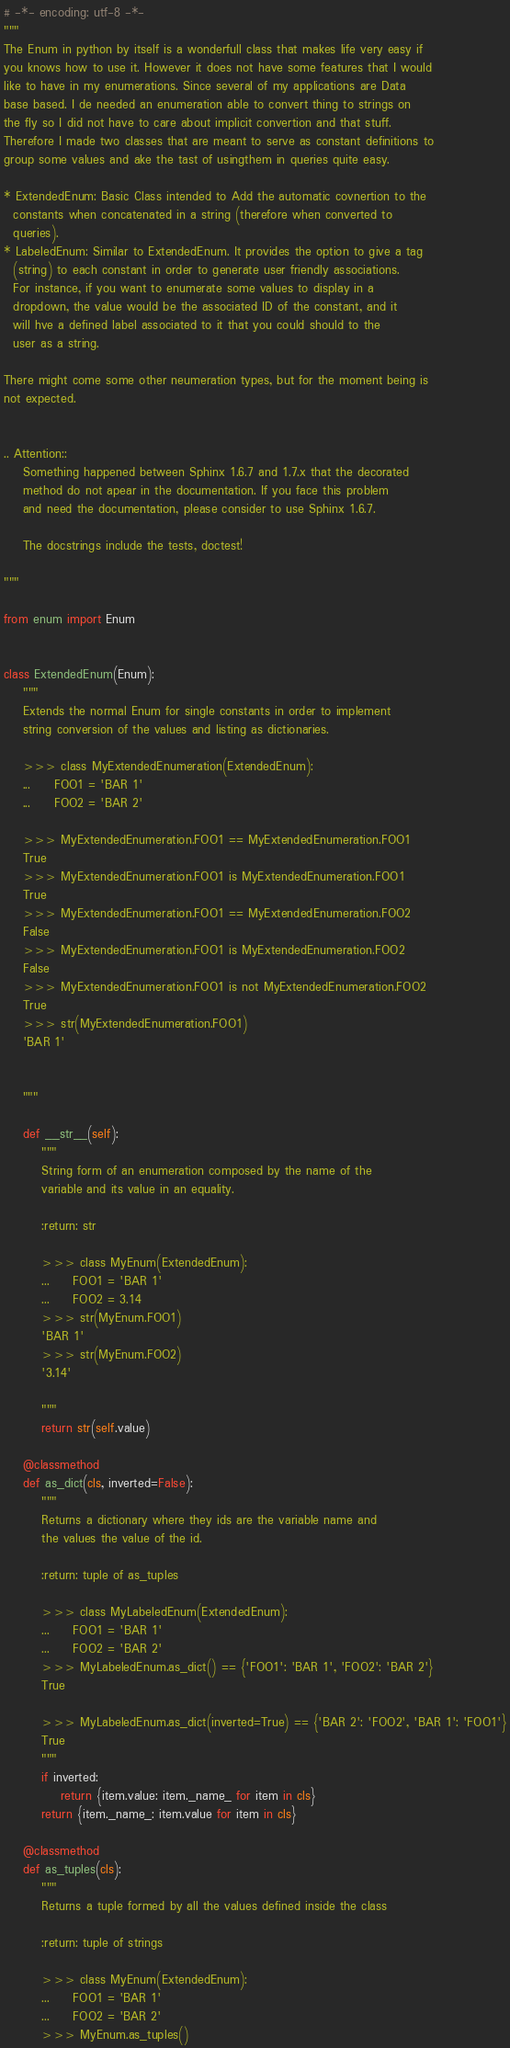<code> <loc_0><loc_0><loc_500><loc_500><_Python_># -*- encoding: utf-8 -*-
"""
The Enum in python by itself is a wonderfull class that makes life very easy if
you knows how to use it. However it does not have some features that I would
like to have in my enumerations. Since several of my applications are Data
base based. I de needed an enumeration able to convert thing to strings on
the fly so I did not have to care about implicit convertion and that stuff.
Therefore I made two classes that are meant to serve as constant definitions to
group some values and ake the tast of usingthem in queries quite easy.

* ExtendedEnum: Basic Class intended to Add the automatic covnertion to the
  constants when concatenated in a string (therefore when converted to
  queries).
* LabeledEnum: Similar to ExtendedEnum. It provides the option to give a tag
  (string) to each constant in order to generate user friendly associations.
  For instance, if you want to enumerate some values to display in a
  dropdown, the value would be the associated ID of the constant, and it
  will hve a defined label associated to it that you could should to the
  user as a string.

There might come some other neumeration types, but for the moment being is
not expected.


.. Attention::
    Something happened between Sphinx 1.6.7 and 1.7.x that the decorated
    method do not apear in the documentation. If you face this problem
    and need the documentation, please consider to use Sphinx 1.6.7.

    The docstrings include the tests, doctest!

"""

from enum import Enum


class ExtendedEnum(Enum):
    """
    Extends the normal Enum for single constants in order to implement
    string conversion of the values and listing as dictionaries.

    >>> class MyExtendedEnumeration(ExtendedEnum):
    ...     FOO1 = 'BAR 1'
    ...     FOO2 = 'BAR 2'

    >>> MyExtendedEnumeration.FOO1 == MyExtendedEnumeration.FOO1
    True
    >>> MyExtendedEnumeration.FOO1 is MyExtendedEnumeration.FOO1
    True
    >>> MyExtendedEnumeration.FOO1 == MyExtendedEnumeration.FOO2
    False
    >>> MyExtendedEnumeration.FOO1 is MyExtendedEnumeration.FOO2
    False
    >>> MyExtendedEnumeration.FOO1 is not MyExtendedEnumeration.FOO2
    True
    >>> str(MyExtendedEnumeration.FOO1)
    'BAR 1'


    """

    def __str__(self):
        """
        String form of an enumeration composed by the name of the
        variable and its value in an equality.

        :return: str

        >>> class MyEnum(ExtendedEnum):
        ...     FOO1 = 'BAR 1'
        ...     FOO2 = 3.14
        >>> str(MyEnum.FOO1)
        'BAR 1'
        >>> str(MyEnum.FOO2)
        '3.14'

        """
        return str(self.value)

    @classmethod
    def as_dict(cls, inverted=False):
        """
        Returns a dictionary where they ids are the variable name and
        the values the value of the id.

        :return: tuple of as_tuples

        >>> class MyLabeledEnum(ExtendedEnum):
        ...     FOO1 = 'BAR 1'
        ...     FOO2 = 'BAR 2'
        >>> MyLabeledEnum.as_dict() == {'FOO1': 'BAR 1', 'FOO2': 'BAR 2'}
        True

        >>> MyLabeledEnum.as_dict(inverted=True) == {'BAR 2': 'FOO2', 'BAR 1': 'FOO1'}
        True
        """
        if inverted:
            return {item.value: item._name_ for item in cls}
        return {item._name_: item.value for item in cls}

    @classmethod
    def as_tuples(cls):
        """
        Returns a tuple formed by all the values defined inside the class

        :return: tuple of strings

        >>> class MyEnum(ExtendedEnum):
        ...     FOO1 = 'BAR 1'
        ...     FOO2 = 'BAR 2'
        >>> MyEnum.as_tuples()</code> 